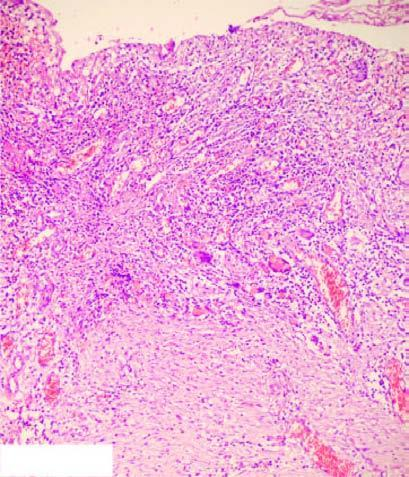re histologic zones of the ulcer illustrated in the diagram?
Answer the question using a single word or phrase. Yes 